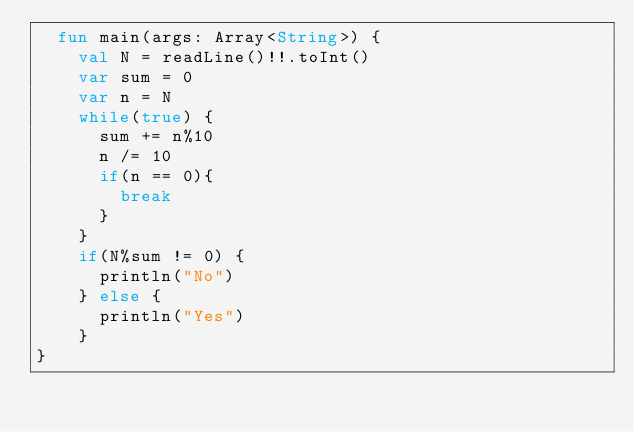Convert code to text. <code><loc_0><loc_0><loc_500><loc_500><_Kotlin_>  fun main(args: Array<String>) {
    val N = readLine()!!.toInt()
    var sum = 0
    var n = N
    while(true) {
      sum += n%10
      n /= 10
      if(n == 0){
        break
      }
    }
    if(N%sum != 0) {
      println("No")
    } else {
      println("Yes")
    }
}</code> 